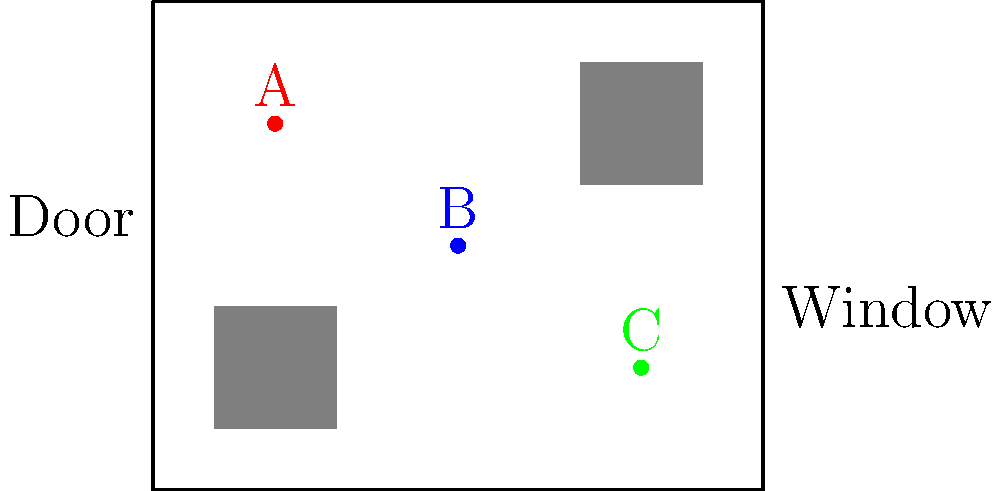In the given top-down floor plan of a scene, three characters (A, B, and C) are positioned as shown. Consider that the scene involves a tense confrontation between these characters. How would you rearrange their positions to create maximum dramatic tension, and why? To create maximum dramatic tension in this scene, we should consider the following steps:

1. Analyze the current positions:
   - Character A is near the top left corner
   - Character B is in the center
   - Character C is near the bottom right corner

2. Consider the room's features:
   - There's a door on the left wall
   - There's a window on the right wall
   - Two pieces of furniture are present (likely a table and a couch)

3. Principles for creating tension:
   - Proximity: Closer characters create more tension
   - Triangle formation: Creates visual interest and implied connections
   - Use of space: Utilize the room's features for storytelling

4. Proposed rearrangement:
   - Move Character A near the door (e.g., (1,4.5))
   - Position Character B in the center, but closer to C (e.g., (6,3))
   - Keep Character C near the window (e.g., (9,3))

5. Justification:
   - This forms a triangle, creating visual tension
   - A is near the exit, suggesting potential for escape or entry of new characters
   - B and C are closer together, implying a more direct confrontation
   - The window near C could be used for dramatic lighting or as a story element

6. Additional considerations:
   - Ensure clear sight lines between all characters
   - Use furniture to partially obstruct or create barriers between characters
   - Consider the camera position to maximize the impact of this arrangement
Answer: Arrange in a triangle: A near door (1,4.5), B center-right (6,3), C by window (9,3). 